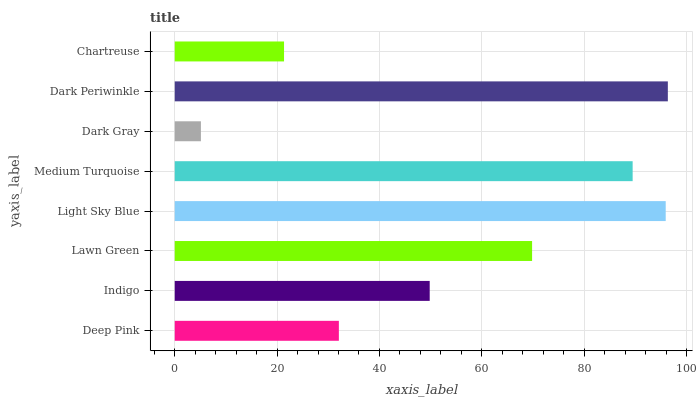Is Dark Gray the minimum?
Answer yes or no. Yes. Is Dark Periwinkle the maximum?
Answer yes or no. Yes. Is Indigo the minimum?
Answer yes or no. No. Is Indigo the maximum?
Answer yes or no. No. Is Indigo greater than Deep Pink?
Answer yes or no. Yes. Is Deep Pink less than Indigo?
Answer yes or no. Yes. Is Deep Pink greater than Indigo?
Answer yes or no. No. Is Indigo less than Deep Pink?
Answer yes or no. No. Is Lawn Green the high median?
Answer yes or no. Yes. Is Indigo the low median?
Answer yes or no. Yes. Is Light Sky Blue the high median?
Answer yes or no. No. Is Medium Turquoise the low median?
Answer yes or no. No. 